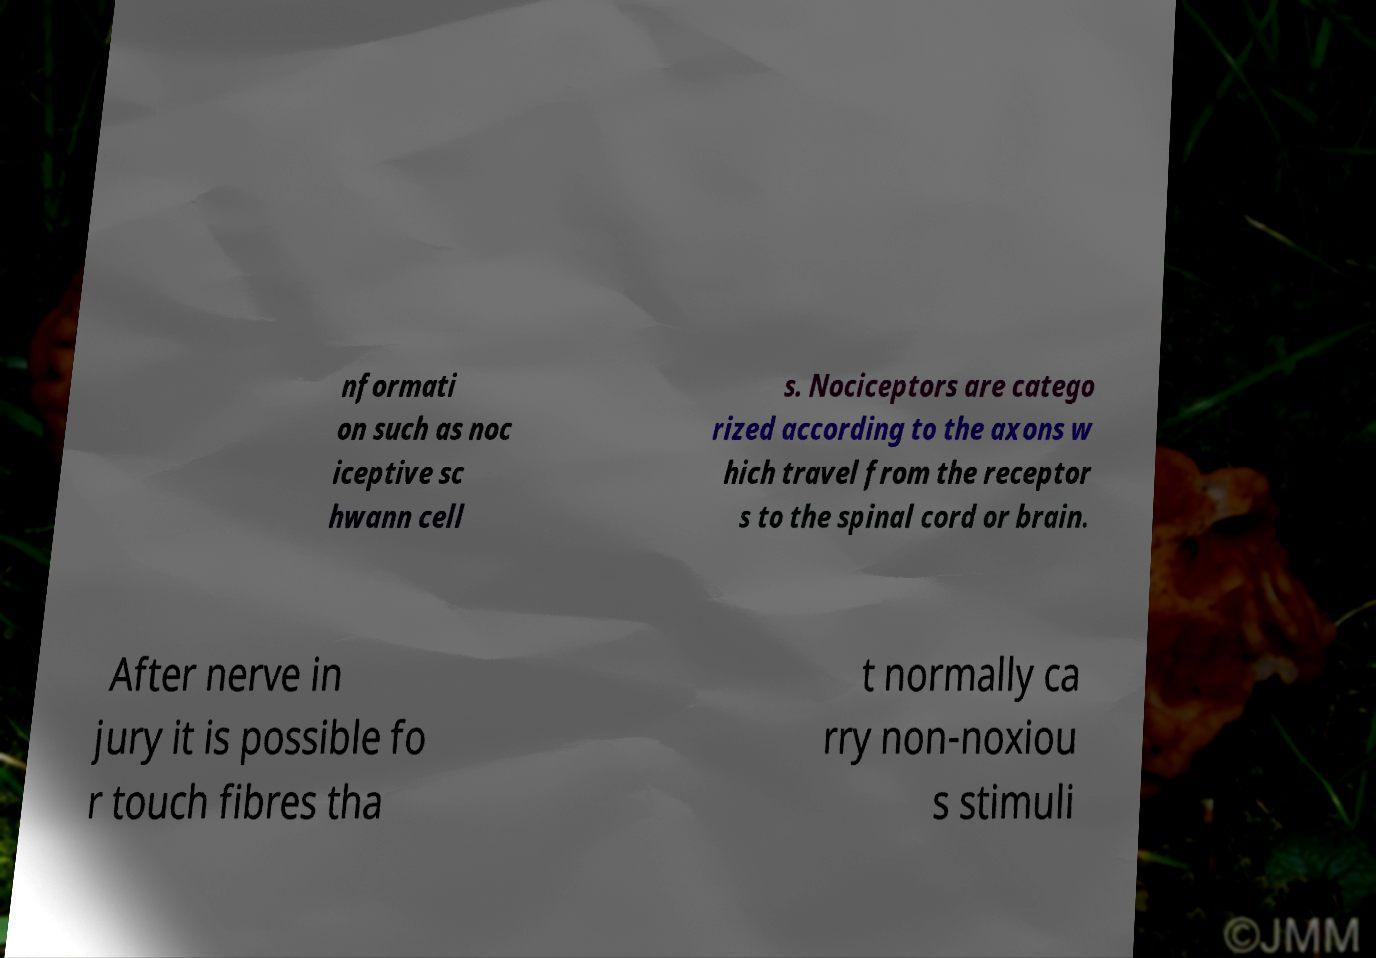What messages or text are displayed in this image? I need them in a readable, typed format. nformati on such as noc iceptive sc hwann cell s. Nociceptors are catego rized according to the axons w hich travel from the receptor s to the spinal cord or brain. After nerve in jury it is possible fo r touch fibres tha t normally ca rry non-noxiou s stimuli 